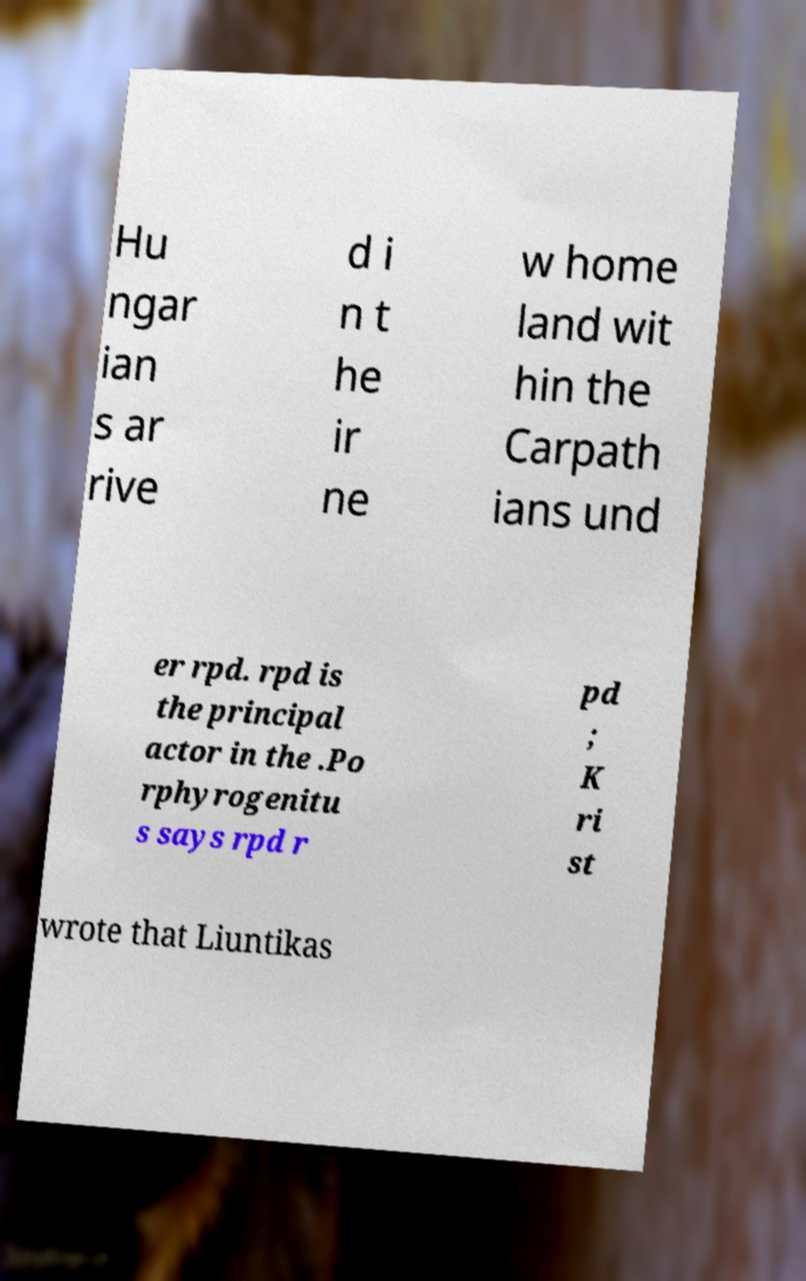For documentation purposes, I need the text within this image transcribed. Could you provide that? Hu ngar ian s ar rive d i n t he ir ne w home land wit hin the Carpath ians und er rpd. rpd is the principal actor in the .Po rphyrogenitu s says rpd r pd ; K ri st wrote that Liuntikas 